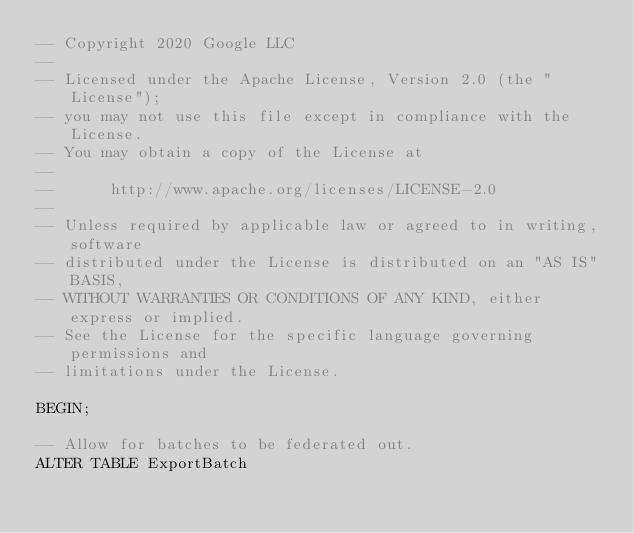<code> <loc_0><loc_0><loc_500><loc_500><_SQL_>-- Copyright 2020 Google LLC
--
-- Licensed under the Apache License, Version 2.0 (the "License");
-- you may not use this file except in compliance with the License.
-- You may obtain a copy of the License at
--
--      http://www.apache.org/licenses/LICENSE-2.0
--
-- Unless required by applicable law or agreed to in writing, software
-- distributed under the License is distributed on an "AS IS" BASIS,
-- WITHOUT WARRANTIES OR CONDITIONS OF ANY KIND, either express or implied.
-- See the License for the specific language governing permissions and
-- limitations under the License.

BEGIN;

-- Allow for batches to be federated out. 
ALTER TABLE ExportBatch</code> 